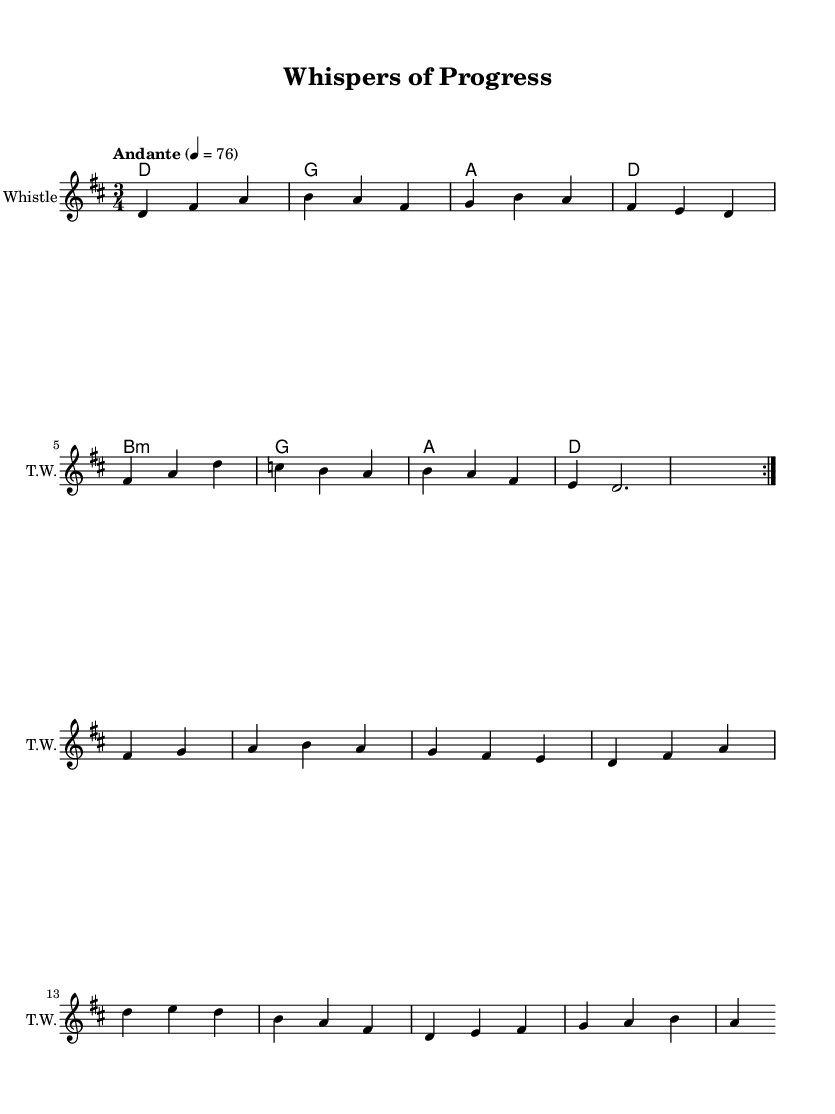What is the key signature of this music? The key signature is D major, which has two sharps (F# and C#). This can be identified by looking at the key signature at the beginning of the staff.
Answer: D major What is the time signature of this piece? The time signature is 3/4, indicating that there are three beats per measure and a quarter note gets one beat. This can be recognized from the two numbers at the beginning of the staff.
Answer: 3/4 What is the tempo marking given for this piece? The tempo marking is "Andante," suggesting a moderately slow tempo. This is noted in the tempo direction indicated above the staff.
Answer: Andante How many measures are repeated in the first section? The first section has a repeat sign, which indicates that the melody is meant to be played again, totaling two measures in the repeated section. Each measure contains the same grouping of notes as in the first playthrough.
Answer: 2 What is the name of the instrument indicated in the music sheet? The music represents a part for the "Tin Whistle," which is stated at the beginning of the staff as the instrument name.
Answer: Tin Whistle How many beats are there in the last measure of the melody? The last measure contains a dotted half note, which equals three beats, thereby filling the measure completely in accordance with the established 3/4 time signature.
Answer: 3 